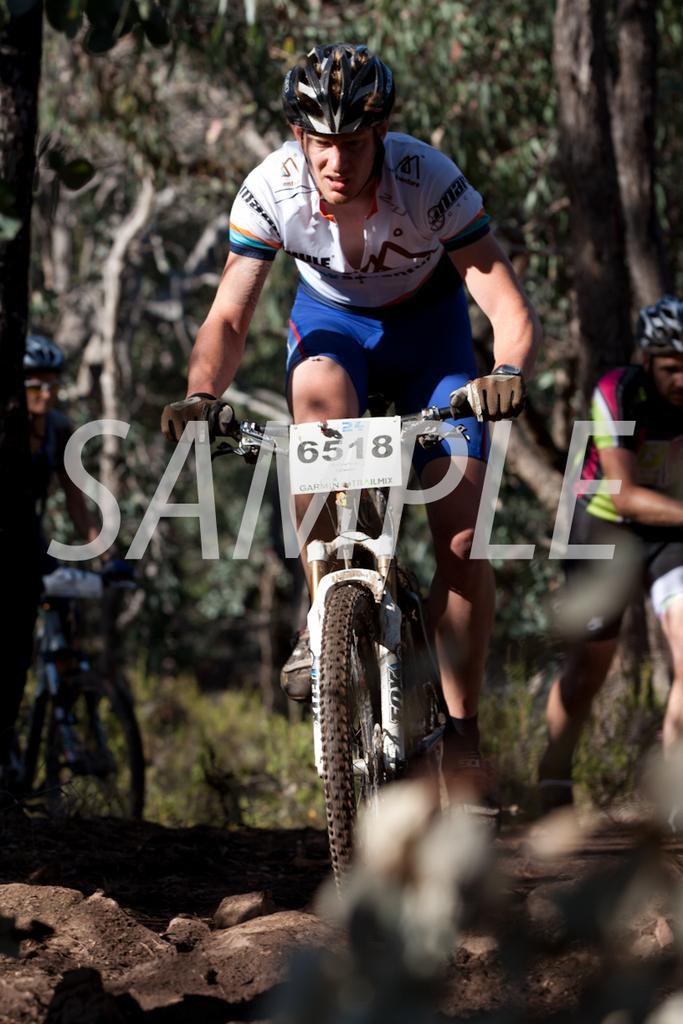Could you give a brief overview of what you see in this image? There is a man who is riding cycle by holding the handle. There is a helmet on his head and a watch to his left hand. There is a number plate to the cycle. In the background there are trees. At the bottom there are rocks. 